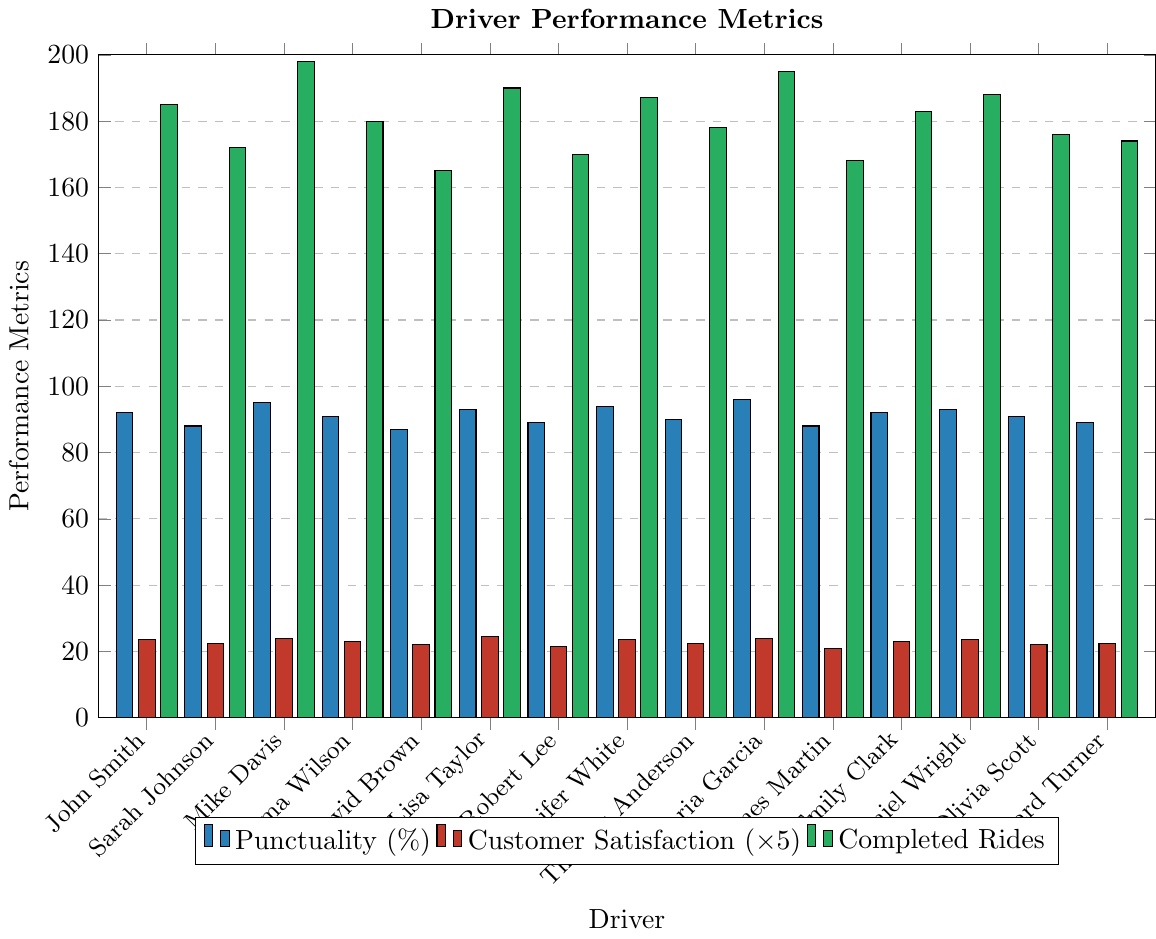Which driver has the highest customer satisfaction score? By observing the height of the red bars, Maria Garcia and Mike Davis both have a customer satisfaction score represented by the tallest bar.
Answer: Mike Davis and Maria Garcia What is the total number of completed rides by Lisa Taylor and Emma Wilson? Adding the heights of the green bars for Lisa Taylor (190) and Emma Wilson (180), the total is 190 + 180 = 370.
Answer: 370 Which driver has the lowest punctuality percentage? The lowest blue bar corresponds to David Brown, with a punctuality percentage of 87%.
Answer: David Brown How many drivers have a completed rides count greater than 185? From the heights of the green bars, drivers John Smith (185), Mike Davis (198), Lisa Taylor (190), Jennifer White (187), Maria Garcia (195), and Daniel Wright (188) all have values greater than 185, totaling 6 drivers.
Answer: 6 What is the average punctuality percentage of Robert Lee and James Martin? Adding the punctuality percentages (blue bars) of Robert Lee (89) and James Martin (88), we get 89 + 88 = 177. Dividing by 2 gives 177/2 = 88.5.
Answer: 88.5 Which drivers have a customer satisfaction score of 4.7? The red bars for John Smith, Jennifer White, and Daniel Wright each represent a score of 4.7.
Answer: John Smith, Jennifer White, and Daniel Wright Who has more completed rides, Sarah Johnson or Olivia Scott, and by how much? Observing the green bars, Sarah Johnson has 172 rides, while Olivia Scott has 176 rides. The difference is 176 - 172 = 4.
Answer: Olivia Scott by 4 rides What is the overall range in punctuality percentage among all drivers? The highest punctuality percentage is 96 (Maria Garcia), and the lowest is 87 (David Brown). The range is 96 - 87 = 9.
Answer: 9 Which driver has the highest combined score of customer satisfaction and punctuality? By adding the blue bar (punctuality) and the red bar (customer satisfaction scaled to 1-5) equivalent on the same scale of 0-100 (multiply customer satisfaction by 20), Maria Garcia has 96 + (4.8*20) = 96 + 96 = 192.
Answer: Maria Garcia 